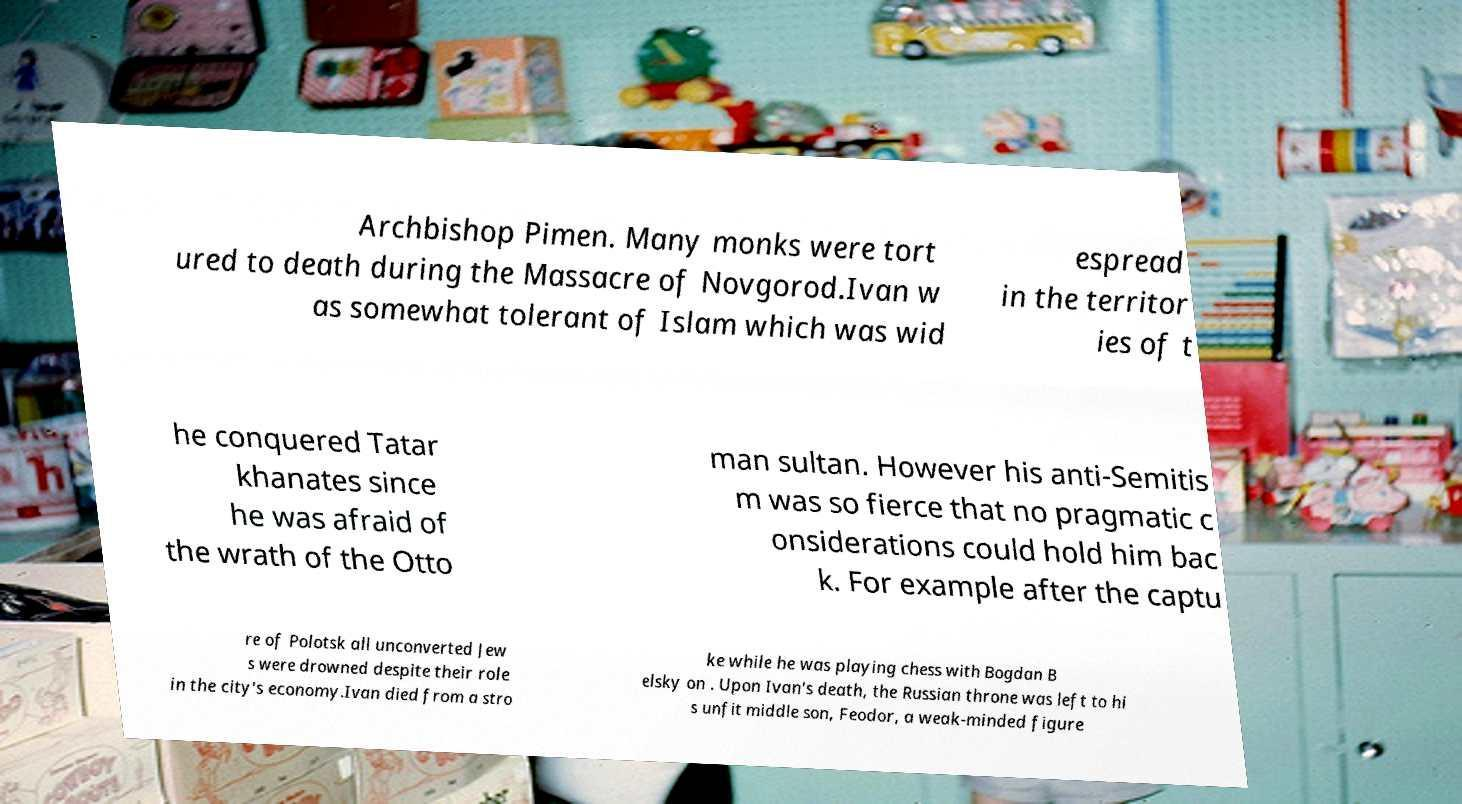Could you assist in decoding the text presented in this image and type it out clearly? Archbishop Pimen. Many monks were tort ured to death during the Massacre of Novgorod.Ivan w as somewhat tolerant of Islam which was wid espread in the territor ies of t he conquered Tatar khanates since he was afraid of the wrath of the Otto man sultan. However his anti-Semitis m was so fierce that no pragmatic c onsiderations could hold him bac k. For example after the captu re of Polotsk all unconverted Jew s were drowned despite their role in the city's economy.Ivan died from a stro ke while he was playing chess with Bogdan B elsky on . Upon Ivan's death, the Russian throne was left to hi s unfit middle son, Feodor, a weak-minded figure 